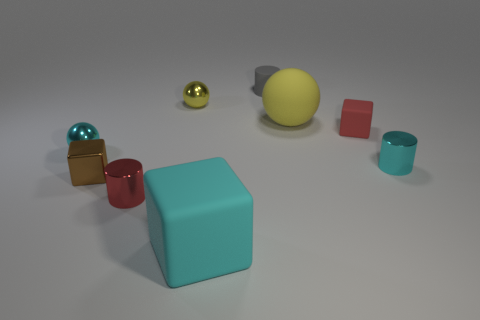What number of cylinders are tiny cyan things or tiny red things?
Your response must be concise. 2. What is the size of the brown cube?
Offer a very short reply. Small. There is a tiny yellow thing; what number of metallic objects are left of it?
Your answer should be very brief. 3. What size is the metallic cylinder on the right side of the tiny shiny cylinder in front of the brown shiny cube?
Provide a short and direct response. Small. Does the rubber object in front of the cyan ball have the same shape as the cyan object that is to the left of the tiny yellow sphere?
Your answer should be compact. No. There is a cyan thing in front of the red thing left of the matte cylinder; what is its shape?
Your response must be concise. Cube. There is a object that is in front of the yellow shiny ball and behind the red matte thing; what size is it?
Keep it short and to the point. Large. There is a brown thing; does it have the same shape as the big matte thing that is to the right of the cyan rubber thing?
Offer a very short reply. No. What size is the cyan shiny object that is the same shape as the small gray matte thing?
Provide a succinct answer. Small. Is the color of the small matte cylinder the same as the matte block behind the cyan rubber cube?
Your answer should be very brief. No. 